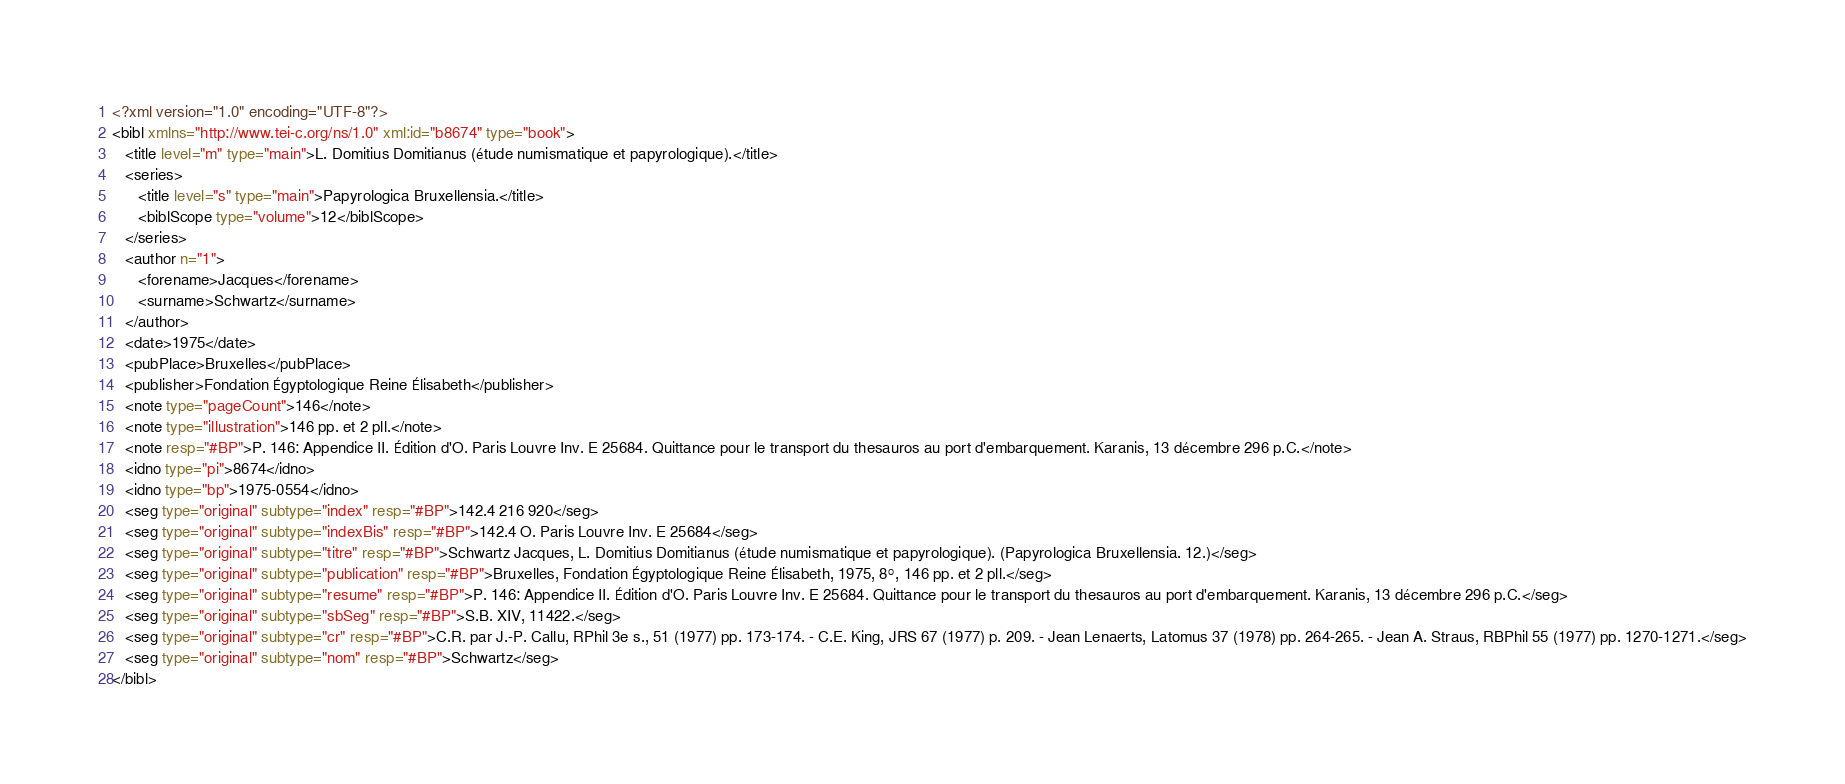Convert code to text. <code><loc_0><loc_0><loc_500><loc_500><_XML_><?xml version="1.0" encoding="UTF-8"?>
<bibl xmlns="http://www.tei-c.org/ns/1.0" xml:id="b8674" type="book">
   <title level="m" type="main">L. Domitius Domitianus (étude numismatique et papyrologique).</title>
   <series>
      <title level="s" type="main">Papyrologica Bruxellensia.</title>
      <biblScope type="volume">12</biblScope>
   </series>
   <author n="1">
      <forename>Jacques</forename>
      <surname>Schwartz</surname>
   </author>
   <date>1975</date>
   <pubPlace>Bruxelles</pubPlace>
   <publisher>Fondation Égyptologique Reine Élisabeth</publisher>
   <note type="pageCount">146</note>
   <note type="illustration">146 pp. et 2 pll.</note>
   <note resp="#BP">P. 146: Appendice II. Édition d'O. Paris Louvre Inv. E 25684. Quittance pour le transport du thesauros au port d'embarquement. Karanis, 13 décembre 296 p.C.</note>
   <idno type="pi">8674</idno>
   <idno type="bp">1975-0554</idno>
   <seg type="original" subtype="index" resp="#BP">142.4 216 920</seg>
   <seg type="original" subtype="indexBis" resp="#BP">142.4 O. Paris Louvre Inv. E 25684</seg>
   <seg type="original" subtype="titre" resp="#BP">Schwartz Jacques, L. Domitius Domitianus (étude numismatique et papyrologique). (Papyrologica Bruxellensia. 12.)</seg>
   <seg type="original" subtype="publication" resp="#BP">Bruxelles, Fondation Égyptologique Reine Élisabeth, 1975, 8°, 146 pp. et 2 pll.</seg>
   <seg type="original" subtype="resume" resp="#BP">P. 146: Appendice II. Édition d'O. Paris Louvre Inv. E 25684. Quittance pour le transport du thesauros au port d'embarquement. Karanis, 13 décembre 296 p.C.</seg>
   <seg type="original" subtype="sbSeg" resp="#BP">S.B. XIV, 11422.</seg>
   <seg type="original" subtype="cr" resp="#BP">C.R. par J.-P. Callu, RPhil 3e s., 51 (1977) pp. 173-174. - C.E. King, JRS 67 (1977) p. 209. - Jean Lenaerts, Latomus 37 (1978) pp. 264-265. - Jean A. Straus, RBPhil 55 (1977) pp. 1270-1271.</seg>
   <seg type="original" subtype="nom" resp="#BP">Schwartz</seg>
</bibl>
</code> 